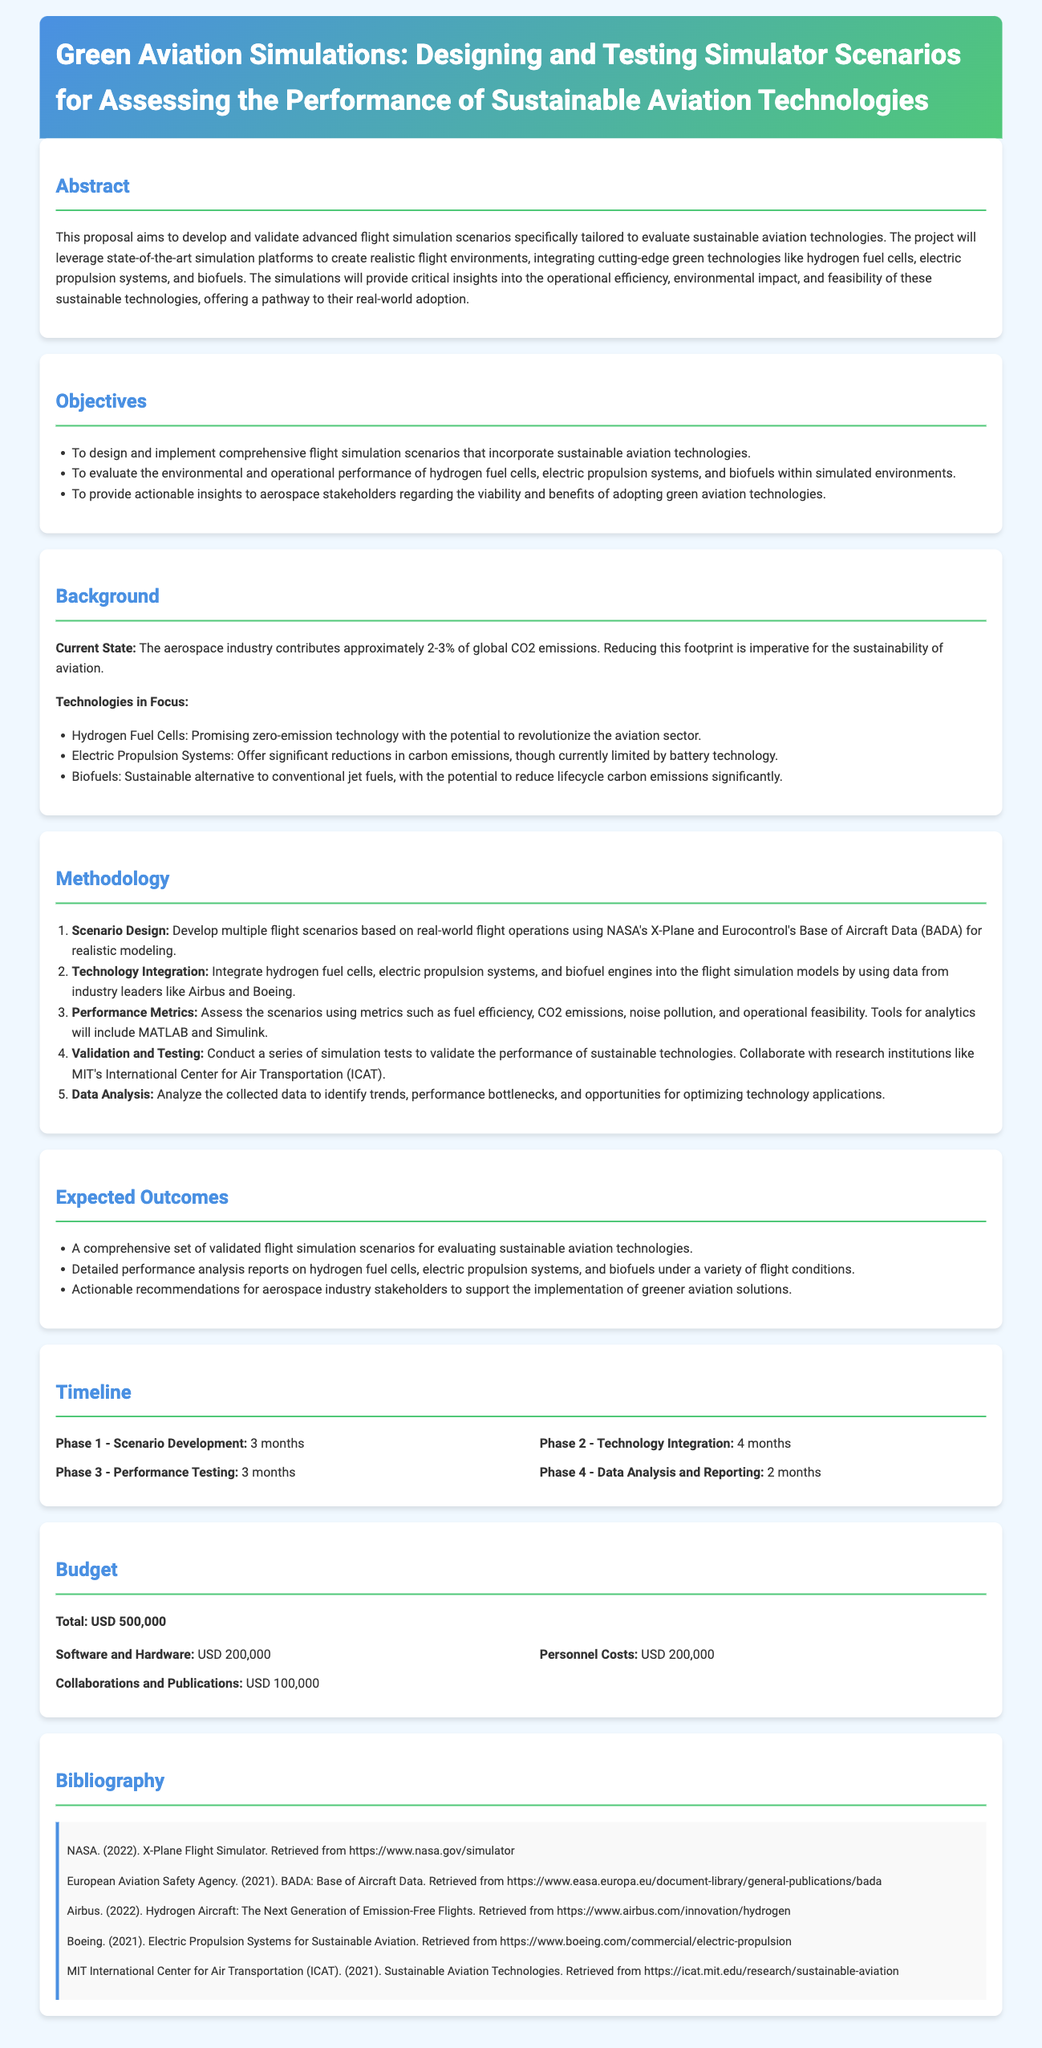What is the total budget for the proposal? The total budget is clearly stated in the document as USD 500,000.
Answer: USD 500,000 What are the three sustainable aviation technologies mentioned? The proposal specifies hydrogen fuel cells, electric propulsion systems, and biofuels as the technologies in focus.
Answer: Hydrogen fuel cells, electric propulsion systems, biofuels What is the duration of Phase 1 - Scenario Development? The duration for Phase 1 is indicated within the timeline section of the proposal as 3 months.
Answer: 3 months Which organization is collaborating for validation and testing? The document identifies MIT's International Center for Air Transportation (ICAT) as a research institution for collaboration.
Answer: MIT's International Center for Air Transportation (ICAT) What is the focus of the proposed flight simulations? The primary focus of the simulations is to evaluate sustainable aviation technologies.
Answer: Evaluate sustainable aviation technologies How many phases are there in the project timeline? The timeline section outlines four distinct phases in the project.
Answer: 4 What type of analytics tools will be used in the project? The proposal mentions using MATLAB and Simulink for analytics assessment.
Answer: MATLAB and Simulink What is the expected outcome regarding performance analysis reports? The expected outcome includes detailed performance analysis reports on sustainable aviation technologies.
Answer: Detailed performance analysis reports 